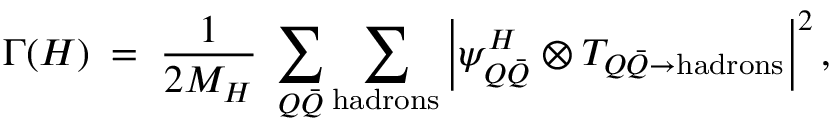Convert formula to latex. <formula><loc_0><loc_0><loc_500><loc_500>\Gamma ( H ) \, = \, { \frac { 1 } { 2 M _ { H } } } \, \sum _ { Q \bar { Q } } \sum _ { h a d r o n s } \left | \psi _ { Q \bar { Q } } ^ { H } \otimes T _ { Q \bar { Q } \to h a d r o n s } \right | ^ { 2 } ,</formula> 